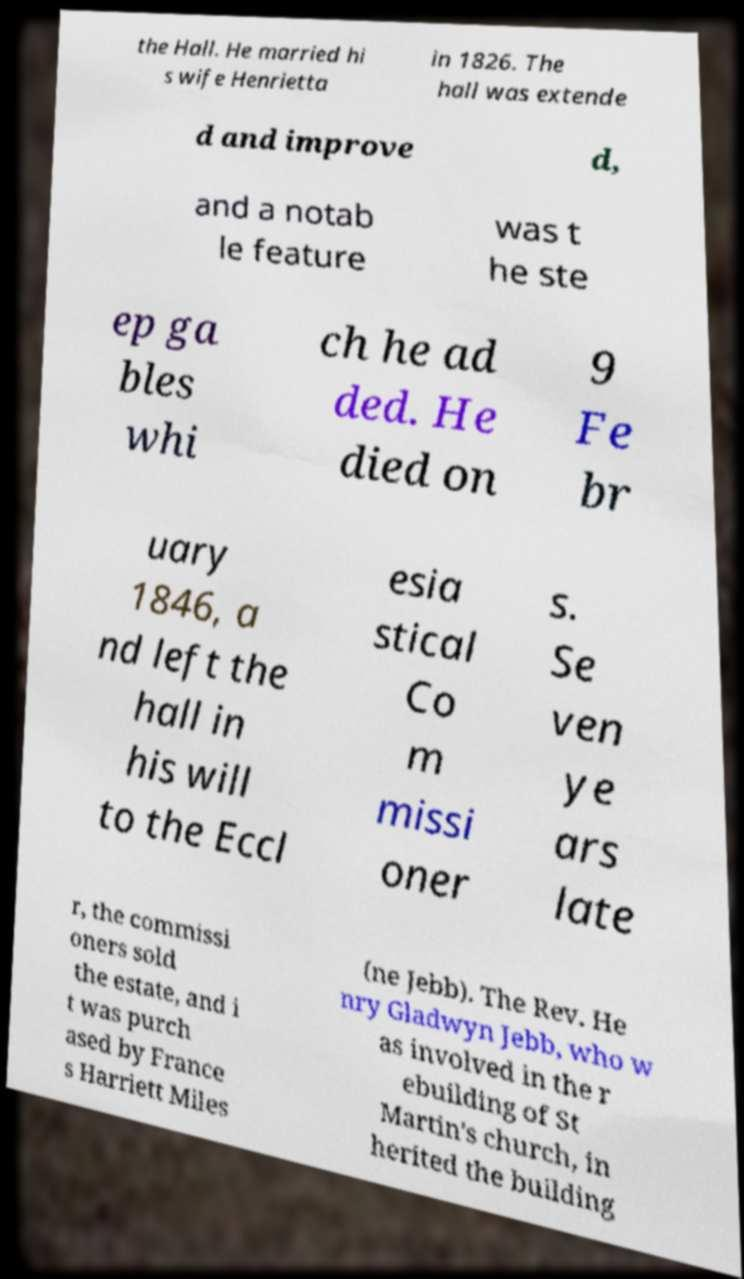Please identify and transcribe the text found in this image. the Hall. He married hi s wife Henrietta in 1826. The hall was extende d and improve d, and a notab le feature was t he ste ep ga bles whi ch he ad ded. He died on 9 Fe br uary 1846, a nd left the hall in his will to the Eccl esia stical Co m missi oner s. Se ven ye ars late r, the commissi oners sold the estate, and i t was purch ased by France s Harriett Miles (ne Jebb). The Rev. He nry Gladwyn Jebb, who w as involved in the r ebuilding of St Martin's church, in herited the building 